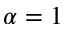<formula> <loc_0><loc_0><loc_500><loc_500>\alpha = 1</formula> 